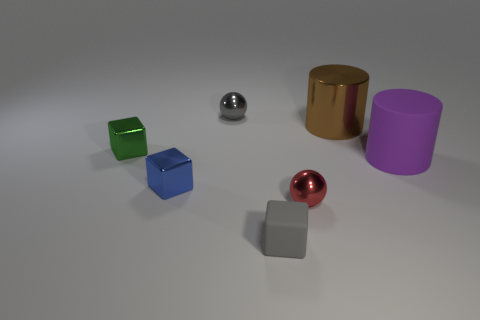Subtract 1 blocks. How many blocks are left? 2 Subtract all tiny metallic cubes. How many cubes are left? 1 Add 3 tiny shiny cubes. How many objects exist? 10 Subtract all blocks. How many objects are left? 4 Add 1 big things. How many big things are left? 3 Add 3 tiny blue metallic blocks. How many tiny blue metallic blocks exist? 4 Subtract 0 brown balls. How many objects are left? 7 Subtract all brown shiny things. Subtract all gray metal things. How many objects are left? 5 